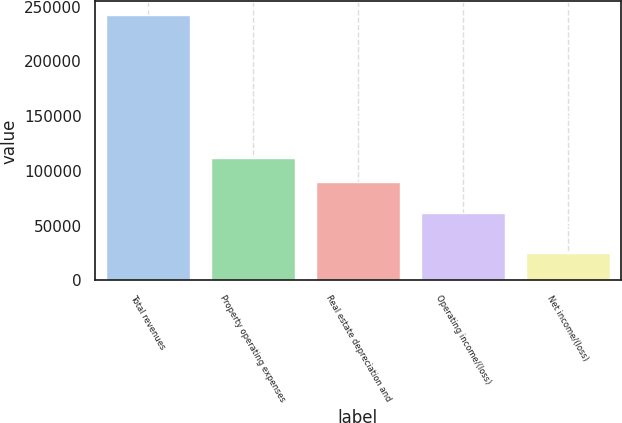Convert chart to OTSL. <chart><loc_0><loc_0><loc_500><loc_500><bar_chart><fcel>Total revenues<fcel>Property operating expenses<fcel>Real estate depreciation and<fcel>Operating income/(loss)<fcel>Net income/(loss)<nl><fcel>242630<fcel>111769<fcel>90037<fcel>61389<fcel>25310<nl></chart> 